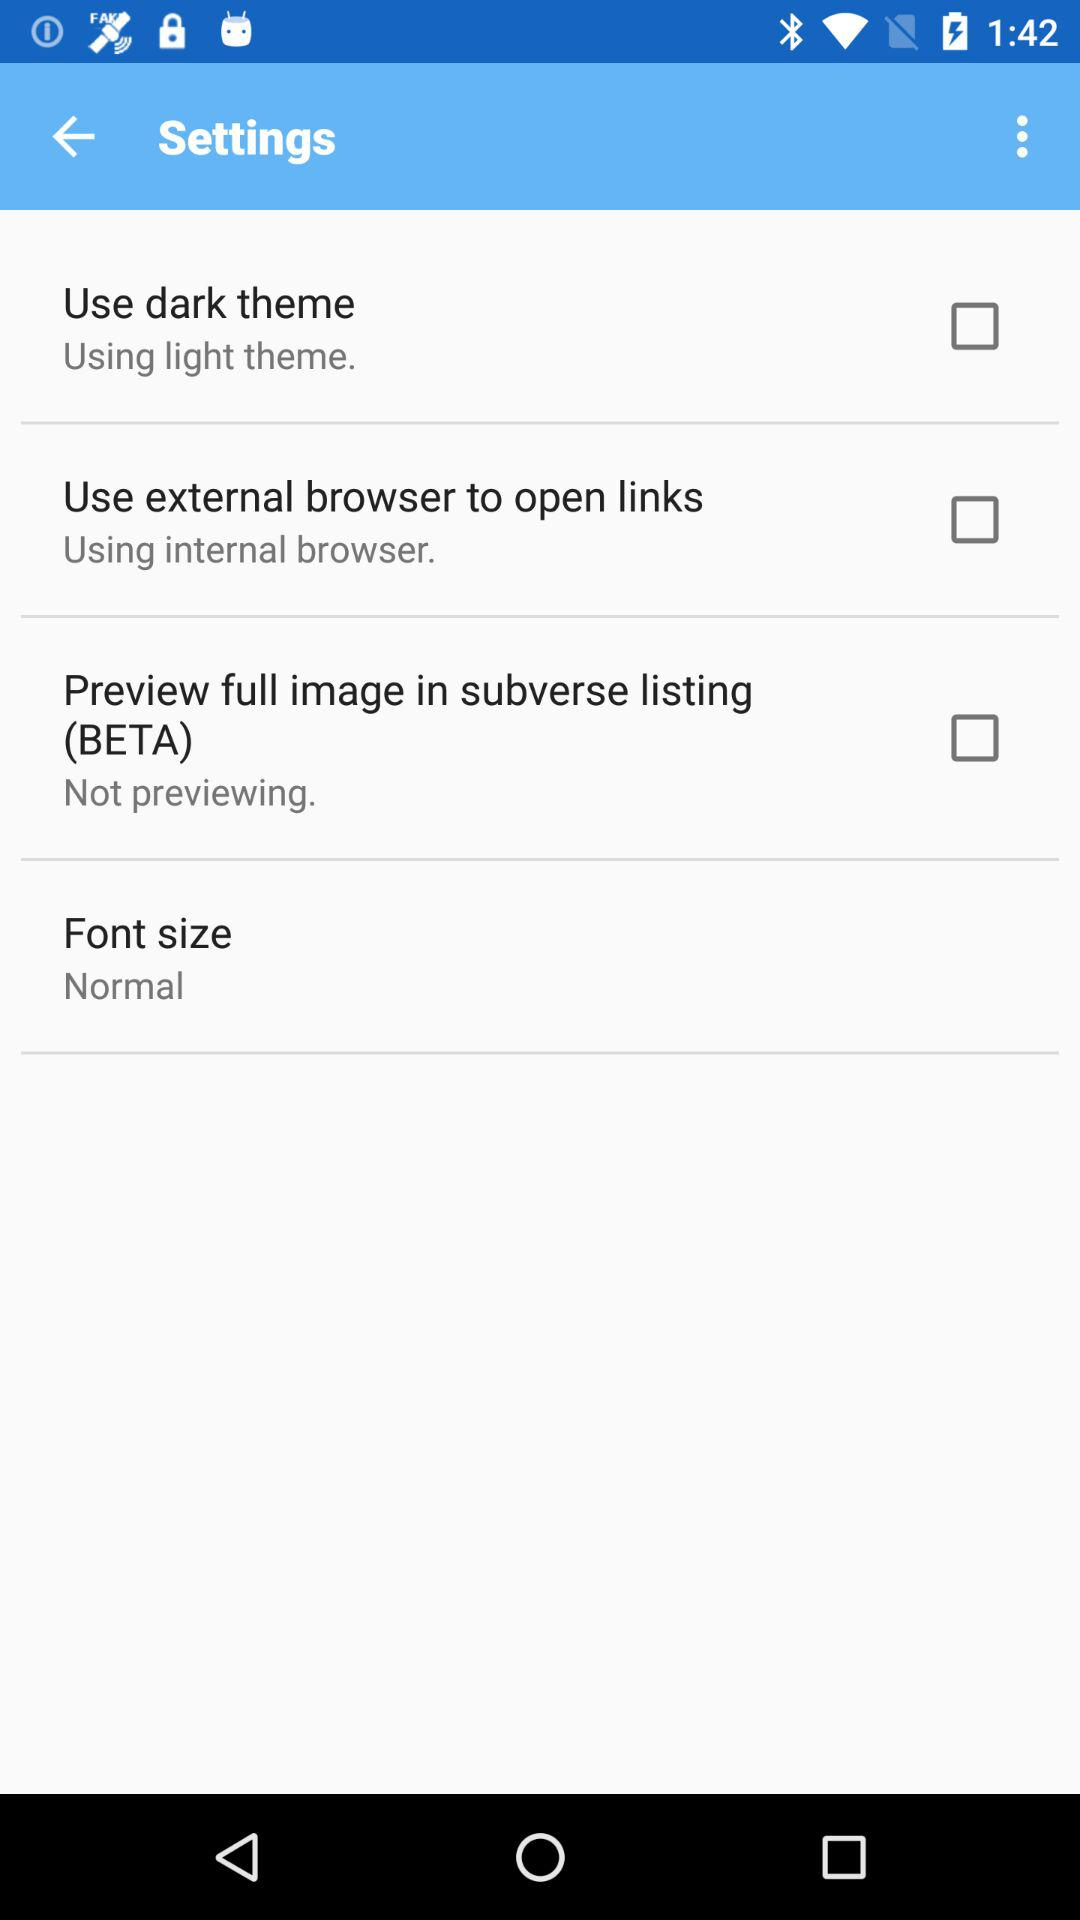What is the status of "Use dark theme"? The status is "off". 